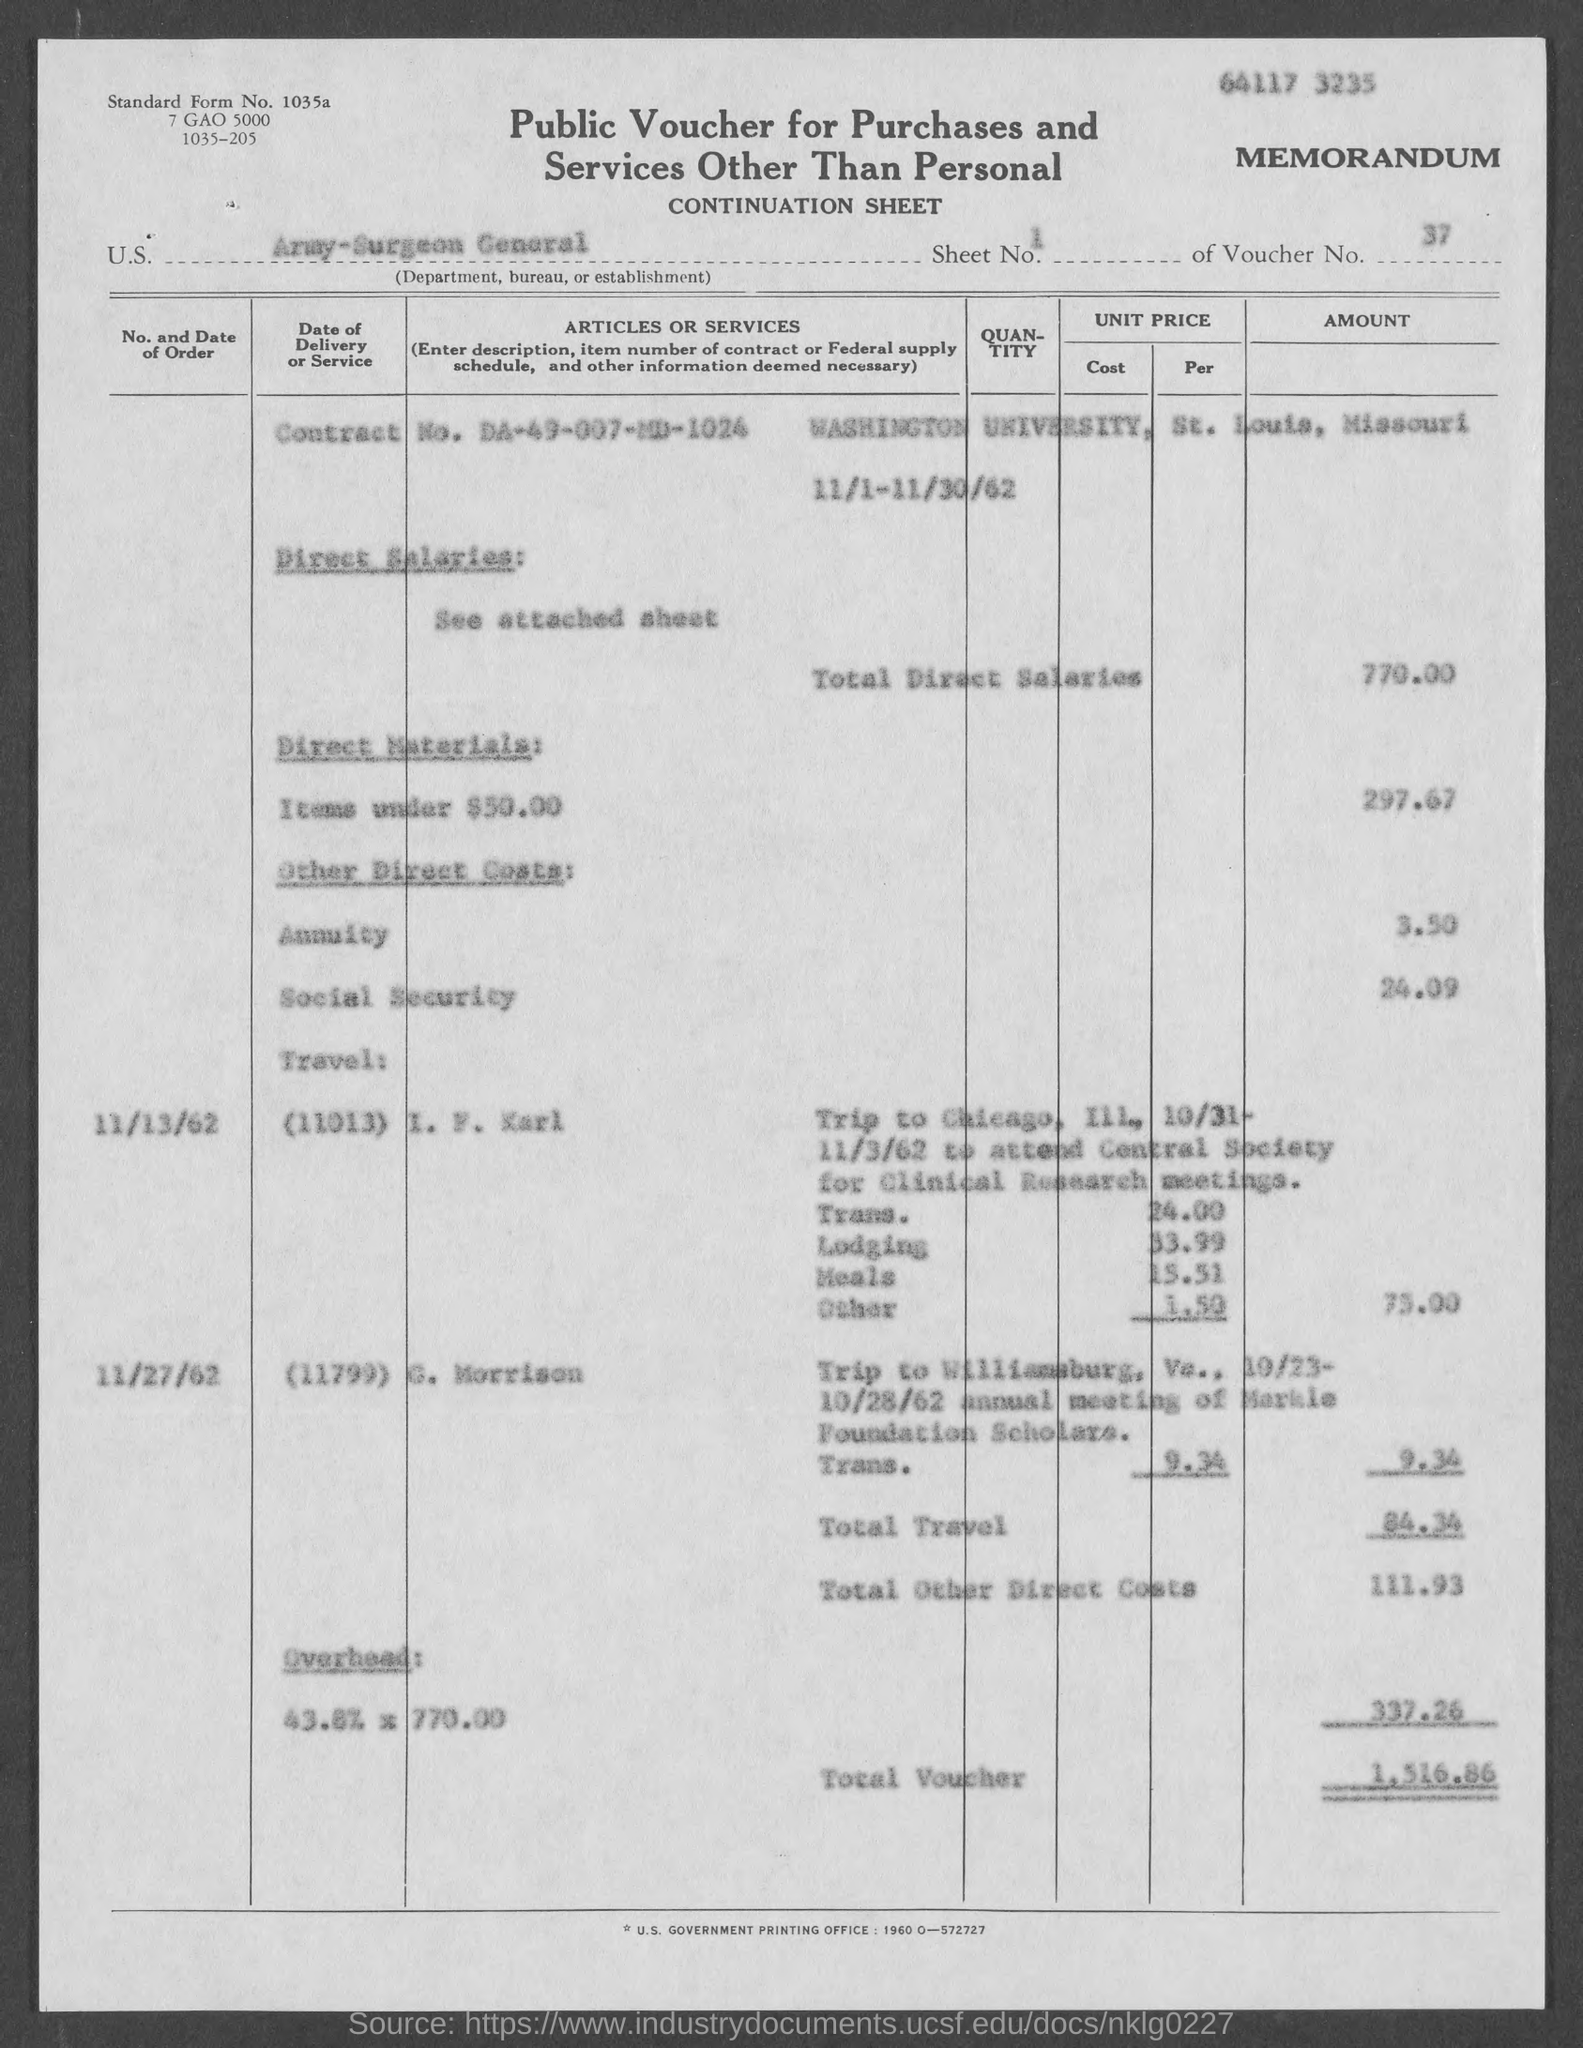Give some essential details in this illustration. The amount for total direct salaries mentioned in the provided page is 770.00. The voucher number mentioned in the given form is 37. The contract number mentioned in the given form is DA-49-007-MD-1024. The amount for the annuity mentioned in the given form is 3.50. The total other direct costs mentioned in the given form are 111.93...," according to the form provided. 